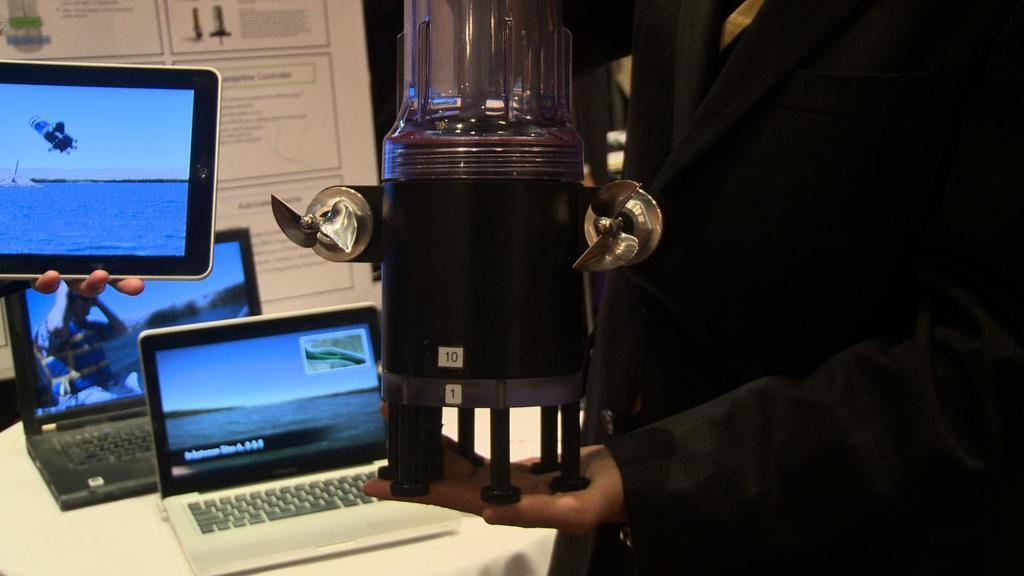<image>
Relay a brief, clear account of the picture shown. laptops behind a man holding a coffee maker with a tag number 10 